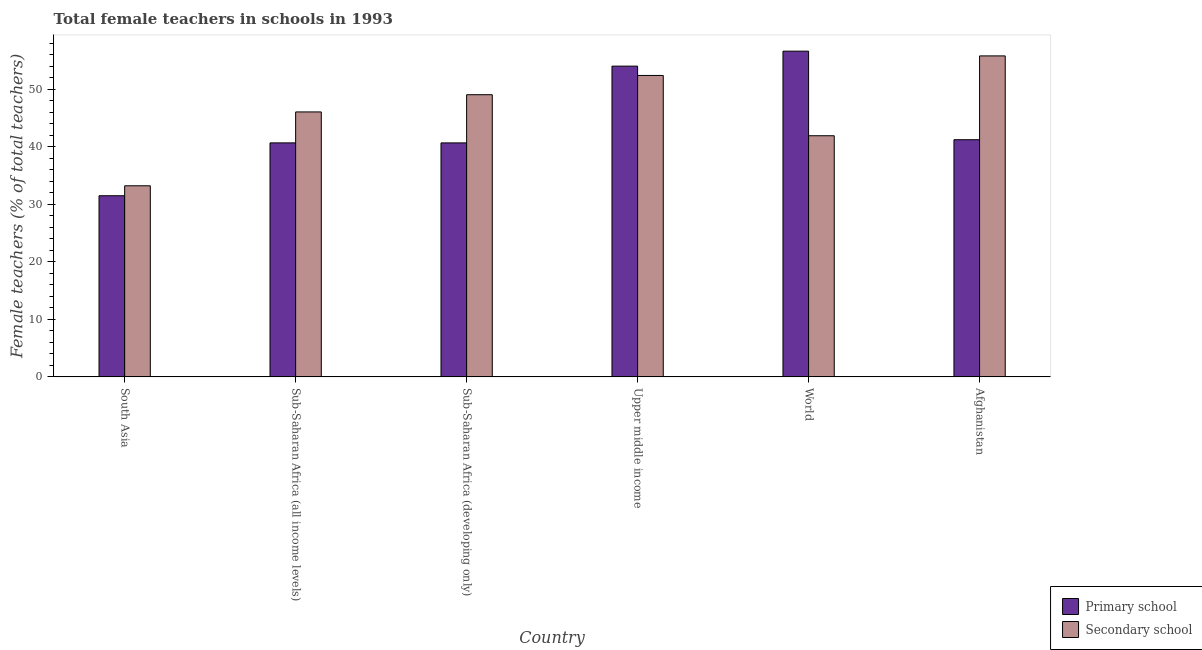Are the number of bars per tick equal to the number of legend labels?
Keep it short and to the point. Yes. Are the number of bars on each tick of the X-axis equal?
Offer a very short reply. Yes. How many bars are there on the 3rd tick from the left?
Give a very brief answer. 2. How many bars are there on the 4th tick from the right?
Ensure brevity in your answer.  2. What is the percentage of female teachers in secondary schools in Sub-Saharan Africa (all income levels)?
Your answer should be very brief. 46.06. Across all countries, what is the maximum percentage of female teachers in secondary schools?
Ensure brevity in your answer.  55.79. Across all countries, what is the minimum percentage of female teachers in secondary schools?
Ensure brevity in your answer.  33.22. In which country was the percentage of female teachers in primary schools minimum?
Offer a very short reply. South Asia. What is the total percentage of female teachers in secondary schools in the graph?
Provide a succinct answer. 278.42. What is the difference between the percentage of female teachers in primary schools in Sub-Saharan Africa (developing only) and that in Upper middle income?
Keep it short and to the point. -13.34. What is the difference between the percentage of female teachers in primary schools in Sub-Saharan Africa (all income levels) and the percentage of female teachers in secondary schools in Afghanistan?
Provide a short and direct response. -15.12. What is the average percentage of female teachers in primary schools per country?
Give a very brief answer. 44.12. What is the difference between the percentage of female teachers in secondary schools and percentage of female teachers in primary schools in Afghanistan?
Your response must be concise. 14.57. What is the ratio of the percentage of female teachers in primary schools in South Asia to that in Sub-Saharan Africa (all income levels)?
Your answer should be compact. 0.77. Is the percentage of female teachers in secondary schools in Afghanistan less than that in Sub-Saharan Africa (all income levels)?
Make the answer very short. No. Is the difference between the percentage of female teachers in primary schools in South Asia and Sub-Saharan Africa (all income levels) greater than the difference between the percentage of female teachers in secondary schools in South Asia and Sub-Saharan Africa (all income levels)?
Offer a very short reply. Yes. What is the difference between the highest and the second highest percentage of female teachers in secondary schools?
Ensure brevity in your answer.  3.4. What is the difference between the highest and the lowest percentage of female teachers in primary schools?
Offer a terse response. 25.13. Is the sum of the percentage of female teachers in secondary schools in Sub-Saharan Africa (developing only) and World greater than the maximum percentage of female teachers in primary schools across all countries?
Ensure brevity in your answer.  Yes. What does the 1st bar from the left in South Asia represents?
Give a very brief answer. Primary school. What does the 2nd bar from the right in Sub-Saharan Africa (developing only) represents?
Make the answer very short. Primary school. Are all the bars in the graph horizontal?
Offer a very short reply. No. What is the difference between two consecutive major ticks on the Y-axis?
Make the answer very short. 10. Are the values on the major ticks of Y-axis written in scientific E-notation?
Your answer should be very brief. No. Does the graph contain any zero values?
Your response must be concise. No. What is the title of the graph?
Provide a short and direct response. Total female teachers in schools in 1993. Does "Canada" appear as one of the legend labels in the graph?
Ensure brevity in your answer.  No. What is the label or title of the X-axis?
Offer a very short reply. Country. What is the label or title of the Y-axis?
Offer a very short reply. Female teachers (% of total teachers). What is the Female teachers (% of total teachers) in Primary school in South Asia?
Provide a succinct answer. 31.49. What is the Female teachers (% of total teachers) of Secondary school in South Asia?
Your answer should be compact. 33.22. What is the Female teachers (% of total teachers) of Primary school in Sub-Saharan Africa (all income levels)?
Make the answer very short. 40.68. What is the Female teachers (% of total teachers) of Secondary school in Sub-Saharan Africa (all income levels)?
Make the answer very short. 46.06. What is the Female teachers (% of total teachers) of Primary school in Sub-Saharan Africa (developing only)?
Provide a succinct answer. 40.67. What is the Female teachers (% of total teachers) of Secondary school in Sub-Saharan Africa (developing only)?
Your answer should be very brief. 49.05. What is the Female teachers (% of total teachers) in Primary school in Upper middle income?
Offer a very short reply. 54.02. What is the Female teachers (% of total teachers) in Secondary school in Upper middle income?
Give a very brief answer. 52.39. What is the Female teachers (% of total teachers) of Primary school in World?
Keep it short and to the point. 56.62. What is the Female teachers (% of total teachers) of Secondary school in World?
Ensure brevity in your answer.  41.91. What is the Female teachers (% of total teachers) in Primary school in Afghanistan?
Offer a very short reply. 41.23. What is the Female teachers (% of total teachers) in Secondary school in Afghanistan?
Make the answer very short. 55.79. Across all countries, what is the maximum Female teachers (% of total teachers) in Primary school?
Provide a succinct answer. 56.62. Across all countries, what is the maximum Female teachers (% of total teachers) in Secondary school?
Offer a very short reply. 55.79. Across all countries, what is the minimum Female teachers (% of total teachers) of Primary school?
Offer a terse response. 31.49. Across all countries, what is the minimum Female teachers (% of total teachers) of Secondary school?
Provide a short and direct response. 33.22. What is the total Female teachers (% of total teachers) in Primary school in the graph?
Make the answer very short. 264.69. What is the total Female teachers (% of total teachers) in Secondary school in the graph?
Keep it short and to the point. 278.42. What is the difference between the Female teachers (% of total teachers) in Primary school in South Asia and that in Sub-Saharan Africa (all income levels)?
Offer a very short reply. -9.19. What is the difference between the Female teachers (% of total teachers) of Secondary school in South Asia and that in Sub-Saharan Africa (all income levels)?
Your response must be concise. -12.84. What is the difference between the Female teachers (% of total teachers) in Primary school in South Asia and that in Sub-Saharan Africa (developing only)?
Make the answer very short. -9.19. What is the difference between the Female teachers (% of total teachers) in Secondary school in South Asia and that in Sub-Saharan Africa (developing only)?
Provide a short and direct response. -15.83. What is the difference between the Female teachers (% of total teachers) of Primary school in South Asia and that in Upper middle income?
Keep it short and to the point. -22.53. What is the difference between the Female teachers (% of total teachers) in Secondary school in South Asia and that in Upper middle income?
Your response must be concise. -19.18. What is the difference between the Female teachers (% of total teachers) in Primary school in South Asia and that in World?
Provide a short and direct response. -25.13. What is the difference between the Female teachers (% of total teachers) of Secondary school in South Asia and that in World?
Ensure brevity in your answer.  -8.7. What is the difference between the Female teachers (% of total teachers) of Primary school in South Asia and that in Afghanistan?
Offer a terse response. -9.74. What is the difference between the Female teachers (% of total teachers) of Secondary school in South Asia and that in Afghanistan?
Offer a very short reply. -22.58. What is the difference between the Female teachers (% of total teachers) in Primary school in Sub-Saharan Africa (all income levels) and that in Sub-Saharan Africa (developing only)?
Offer a terse response. 0. What is the difference between the Female teachers (% of total teachers) in Secondary school in Sub-Saharan Africa (all income levels) and that in Sub-Saharan Africa (developing only)?
Provide a succinct answer. -2.99. What is the difference between the Female teachers (% of total teachers) of Primary school in Sub-Saharan Africa (all income levels) and that in Upper middle income?
Your answer should be compact. -13.34. What is the difference between the Female teachers (% of total teachers) in Secondary school in Sub-Saharan Africa (all income levels) and that in Upper middle income?
Provide a short and direct response. -6.34. What is the difference between the Female teachers (% of total teachers) in Primary school in Sub-Saharan Africa (all income levels) and that in World?
Make the answer very short. -15.94. What is the difference between the Female teachers (% of total teachers) in Secondary school in Sub-Saharan Africa (all income levels) and that in World?
Your answer should be very brief. 4.14. What is the difference between the Female teachers (% of total teachers) of Primary school in Sub-Saharan Africa (all income levels) and that in Afghanistan?
Ensure brevity in your answer.  -0.55. What is the difference between the Female teachers (% of total teachers) in Secondary school in Sub-Saharan Africa (all income levels) and that in Afghanistan?
Ensure brevity in your answer.  -9.74. What is the difference between the Female teachers (% of total teachers) in Primary school in Sub-Saharan Africa (developing only) and that in Upper middle income?
Give a very brief answer. -13.34. What is the difference between the Female teachers (% of total teachers) in Secondary school in Sub-Saharan Africa (developing only) and that in Upper middle income?
Ensure brevity in your answer.  -3.35. What is the difference between the Female teachers (% of total teachers) of Primary school in Sub-Saharan Africa (developing only) and that in World?
Provide a succinct answer. -15.95. What is the difference between the Female teachers (% of total teachers) in Secondary school in Sub-Saharan Africa (developing only) and that in World?
Provide a succinct answer. 7.13. What is the difference between the Female teachers (% of total teachers) of Primary school in Sub-Saharan Africa (developing only) and that in Afghanistan?
Provide a short and direct response. -0.55. What is the difference between the Female teachers (% of total teachers) in Secondary school in Sub-Saharan Africa (developing only) and that in Afghanistan?
Offer a terse response. -6.75. What is the difference between the Female teachers (% of total teachers) in Primary school in Upper middle income and that in World?
Your answer should be very brief. -2.6. What is the difference between the Female teachers (% of total teachers) of Secondary school in Upper middle income and that in World?
Give a very brief answer. 10.48. What is the difference between the Female teachers (% of total teachers) in Primary school in Upper middle income and that in Afghanistan?
Offer a terse response. 12.79. What is the difference between the Female teachers (% of total teachers) in Secondary school in Upper middle income and that in Afghanistan?
Offer a very short reply. -3.4. What is the difference between the Female teachers (% of total teachers) of Primary school in World and that in Afghanistan?
Your answer should be compact. 15.39. What is the difference between the Female teachers (% of total teachers) of Secondary school in World and that in Afghanistan?
Offer a terse response. -13.88. What is the difference between the Female teachers (% of total teachers) of Primary school in South Asia and the Female teachers (% of total teachers) of Secondary school in Sub-Saharan Africa (all income levels)?
Provide a succinct answer. -14.57. What is the difference between the Female teachers (% of total teachers) in Primary school in South Asia and the Female teachers (% of total teachers) in Secondary school in Sub-Saharan Africa (developing only)?
Provide a short and direct response. -17.56. What is the difference between the Female teachers (% of total teachers) of Primary school in South Asia and the Female teachers (% of total teachers) of Secondary school in Upper middle income?
Provide a short and direct response. -20.91. What is the difference between the Female teachers (% of total teachers) in Primary school in South Asia and the Female teachers (% of total teachers) in Secondary school in World?
Offer a terse response. -10.43. What is the difference between the Female teachers (% of total teachers) of Primary school in South Asia and the Female teachers (% of total teachers) of Secondary school in Afghanistan?
Provide a short and direct response. -24.31. What is the difference between the Female teachers (% of total teachers) of Primary school in Sub-Saharan Africa (all income levels) and the Female teachers (% of total teachers) of Secondary school in Sub-Saharan Africa (developing only)?
Your answer should be very brief. -8.37. What is the difference between the Female teachers (% of total teachers) in Primary school in Sub-Saharan Africa (all income levels) and the Female teachers (% of total teachers) in Secondary school in Upper middle income?
Keep it short and to the point. -11.72. What is the difference between the Female teachers (% of total teachers) of Primary school in Sub-Saharan Africa (all income levels) and the Female teachers (% of total teachers) of Secondary school in World?
Your response must be concise. -1.24. What is the difference between the Female teachers (% of total teachers) of Primary school in Sub-Saharan Africa (all income levels) and the Female teachers (% of total teachers) of Secondary school in Afghanistan?
Your answer should be compact. -15.12. What is the difference between the Female teachers (% of total teachers) of Primary school in Sub-Saharan Africa (developing only) and the Female teachers (% of total teachers) of Secondary school in Upper middle income?
Your response must be concise. -11.72. What is the difference between the Female teachers (% of total teachers) of Primary school in Sub-Saharan Africa (developing only) and the Female teachers (% of total teachers) of Secondary school in World?
Provide a succinct answer. -1.24. What is the difference between the Female teachers (% of total teachers) of Primary school in Sub-Saharan Africa (developing only) and the Female teachers (% of total teachers) of Secondary school in Afghanistan?
Ensure brevity in your answer.  -15.12. What is the difference between the Female teachers (% of total teachers) in Primary school in Upper middle income and the Female teachers (% of total teachers) in Secondary school in World?
Your answer should be compact. 12.1. What is the difference between the Female teachers (% of total teachers) of Primary school in Upper middle income and the Female teachers (% of total teachers) of Secondary school in Afghanistan?
Your answer should be very brief. -1.78. What is the difference between the Female teachers (% of total teachers) in Primary school in World and the Female teachers (% of total teachers) in Secondary school in Afghanistan?
Offer a terse response. 0.82. What is the average Female teachers (% of total teachers) in Primary school per country?
Your response must be concise. 44.12. What is the average Female teachers (% of total teachers) of Secondary school per country?
Your answer should be very brief. 46.4. What is the difference between the Female teachers (% of total teachers) in Primary school and Female teachers (% of total teachers) in Secondary school in South Asia?
Your answer should be compact. -1.73. What is the difference between the Female teachers (% of total teachers) in Primary school and Female teachers (% of total teachers) in Secondary school in Sub-Saharan Africa (all income levels)?
Make the answer very short. -5.38. What is the difference between the Female teachers (% of total teachers) in Primary school and Female teachers (% of total teachers) in Secondary school in Sub-Saharan Africa (developing only)?
Make the answer very short. -8.38. What is the difference between the Female teachers (% of total teachers) in Primary school and Female teachers (% of total teachers) in Secondary school in Upper middle income?
Offer a terse response. 1.62. What is the difference between the Female teachers (% of total teachers) in Primary school and Female teachers (% of total teachers) in Secondary school in World?
Offer a terse response. 14.7. What is the difference between the Female teachers (% of total teachers) in Primary school and Female teachers (% of total teachers) in Secondary school in Afghanistan?
Offer a very short reply. -14.57. What is the ratio of the Female teachers (% of total teachers) of Primary school in South Asia to that in Sub-Saharan Africa (all income levels)?
Provide a succinct answer. 0.77. What is the ratio of the Female teachers (% of total teachers) of Secondary school in South Asia to that in Sub-Saharan Africa (all income levels)?
Ensure brevity in your answer.  0.72. What is the ratio of the Female teachers (% of total teachers) in Primary school in South Asia to that in Sub-Saharan Africa (developing only)?
Your answer should be very brief. 0.77. What is the ratio of the Female teachers (% of total teachers) of Secondary school in South Asia to that in Sub-Saharan Africa (developing only)?
Make the answer very short. 0.68. What is the ratio of the Female teachers (% of total teachers) in Primary school in South Asia to that in Upper middle income?
Your answer should be very brief. 0.58. What is the ratio of the Female teachers (% of total teachers) in Secondary school in South Asia to that in Upper middle income?
Make the answer very short. 0.63. What is the ratio of the Female teachers (% of total teachers) of Primary school in South Asia to that in World?
Provide a short and direct response. 0.56. What is the ratio of the Female teachers (% of total teachers) of Secondary school in South Asia to that in World?
Ensure brevity in your answer.  0.79. What is the ratio of the Female teachers (% of total teachers) of Primary school in South Asia to that in Afghanistan?
Make the answer very short. 0.76. What is the ratio of the Female teachers (% of total teachers) in Secondary school in South Asia to that in Afghanistan?
Offer a very short reply. 0.6. What is the ratio of the Female teachers (% of total teachers) of Secondary school in Sub-Saharan Africa (all income levels) to that in Sub-Saharan Africa (developing only)?
Offer a terse response. 0.94. What is the ratio of the Female teachers (% of total teachers) of Primary school in Sub-Saharan Africa (all income levels) to that in Upper middle income?
Your answer should be compact. 0.75. What is the ratio of the Female teachers (% of total teachers) of Secondary school in Sub-Saharan Africa (all income levels) to that in Upper middle income?
Give a very brief answer. 0.88. What is the ratio of the Female teachers (% of total teachers) of Primary school in Sub-Saharan Africa (all income levels) to that in World?
Offer a very short reply. 0.72. What is the ratio of the Female teachers (% of total teachers) in Secondary school in Sub-Saharan Africa (all income levels) to that in World?
Give a very brief answer. 1.1. What is the ratio of the Female teachers (% of total teachers) in Primary school in Sub-Saharan Africa (all income levels) to that in Afghanistan?
Make the answer very short. 0.99. What is the ratio of the Female teachers (% of total teachers) in Secondary school in Sub-Saharan Africa (all income levels) to that in Afghanistan?
Ensure brevity in your answer.  0.83. What is the ratio of the Female teachers (% of total teachers) in Primary school in Sub-Saharan Africa (developing only) to that in Upper middle income?
Give a very brief answer. 0.75. What is the ratio of the Female teachers (% of total teachers) of Secondary school in Sub-Saharan Africa (developing only) to that in Upper middle income?
Ensure brevity in your answer.  0.94. What is the ratio of the Female teachers (% of total teachers) in Primary school in Sub-Saharan Africa (developing only) to that in World?
Provide a short and direct response. 0.72. What is the ratio of the Female teachers (% of total teachers) in Secondary school in Sub-Saharan Africa (developing only) to that in World?
Provide a succinct answer. 1.17. What is the ratio of the Female teachers (% of total teachers) in Primary school in Sub-Saharan Africa (developing only) to that in Afghanistan?
Make the answer very short. 0.99. What is the ratio of the Female teachers (% of total teachers) in Secondary school in Sub-Saharan Africa (developing only) to that in Afghanistan?
Keep it short and to the point. 0.88. What is the ratio of the Female teachers (% of total teachers) of Primary school in Upper middle income to that in World?
Give a very brief answer. 0.95. What is the ratio of the Female teachers (% of total teachers) of Secondary school in Upper middle income to that in World?
Provide a succinct answer. 1.25. What is the ratio of the Female teachers (% of total teachers) of Primary school in Upper middle income to that in Afghanistan?
Provide a succinct answer. 1.31. What is the ratio of the Female teachers (% of total teachers) of Secondary school in Upper middle income to that in Afghanistan?
Your answer should be compact. 0.94. What is the ratio of the Female teachers (% of total teachers) of Primary school in World to that in Afghanistan?
Your response must be concise. 1.37. What is the ratio of the Female teachers (% of total teachers) of Secondary school in World to that in Afghanistan?
Your response must be concise. 0.75. What is the difference between the highest and the second highest Female teachers (% of total teachers) in Primary school?
Your answer should be compact. 2.6. What is the difference between the highest and the second highest Female teachers (% of total teachers) in Secondary school?
Provide a succinct answer. 3.4. What is the difference between the highest and the lowest Female teachers (% of total teachers) in Primary school?
Your response must be concise. 25.13. What is the difference between the highest and the lowest Female teachers (% of total teachers) of Secondary school?
Your answer should be compact. 22.58. 